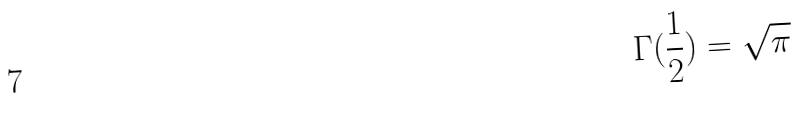<formula> <loc_0><loc_0><loc_500><loc_500>\Gamma ( \frac { 1 } { 2 } ) = \sqrt { \pi }</formula> 